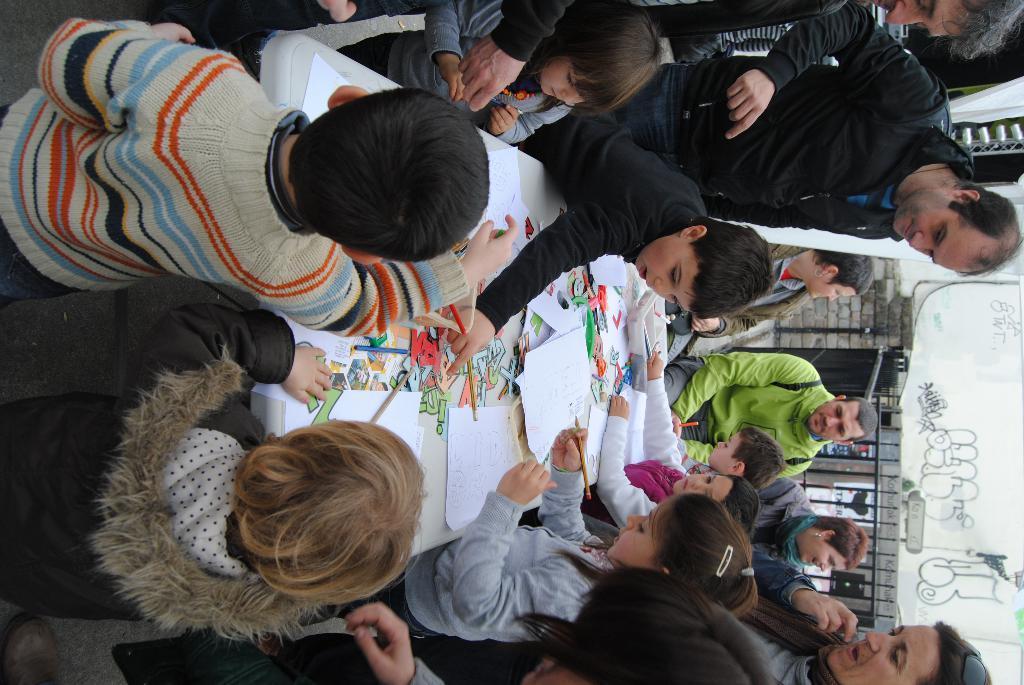In one or two sentences, can you explain what this image depicts? In this image there is a table having few papers and pencils on it. Few kids are around the table. Right side there are few people. Behind them there is a fence. Behind there is a wall having some painting. 